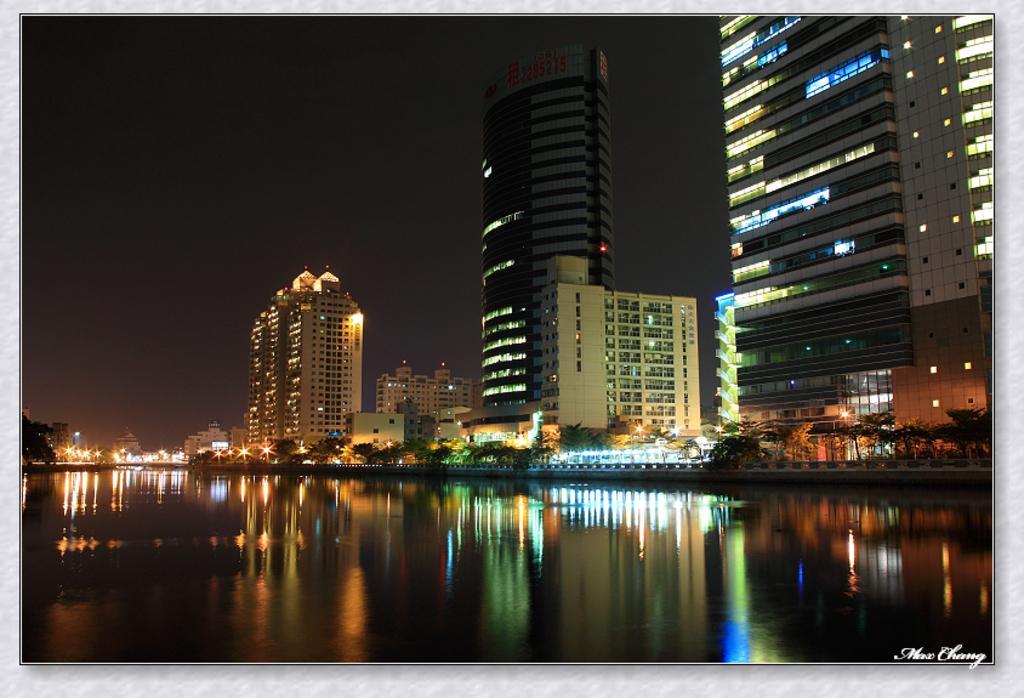Describe this image in one or two sentences. In this image we can see some buildings, there are trees, water and lights, in the background, we can see the sky. 